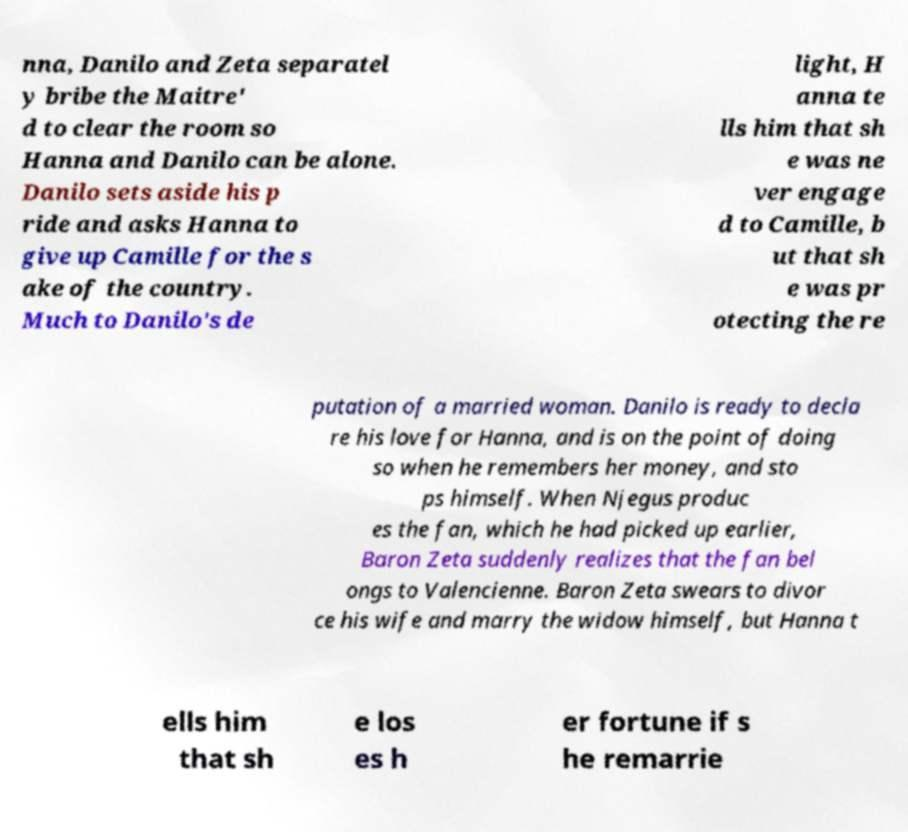Can you read and provide the text displayed in the image?This photo seems to have some interesting text. Can you extract and type it out for me? nna, Danilo and Zeta separatel y bribe the Maitre' d to clear the room so Hanna and Danilo can be alone. Danilo sets aside his p ride and asks Hanna to give up Camille for the s ake of the country. Much to Danilo's de light, H anna te lls him that sh e was ne ver engage d to Camille, b ut that sh e was pr otecting the re putation of a married woman. Danilo is ready to decla re his love for Hanna, and is on the point of doing so when he remembers her money, and sto ps himself. When Njegus produc es the fan, which he had picked up earlier, Baron Zeta suddenly realizes that the fan bel ongs to Valencienne. Baron Zeta swears to divor ce his wife and marry the widow himself, but Hanna t ells him that sh e los es h er fortune if s he remarrie 